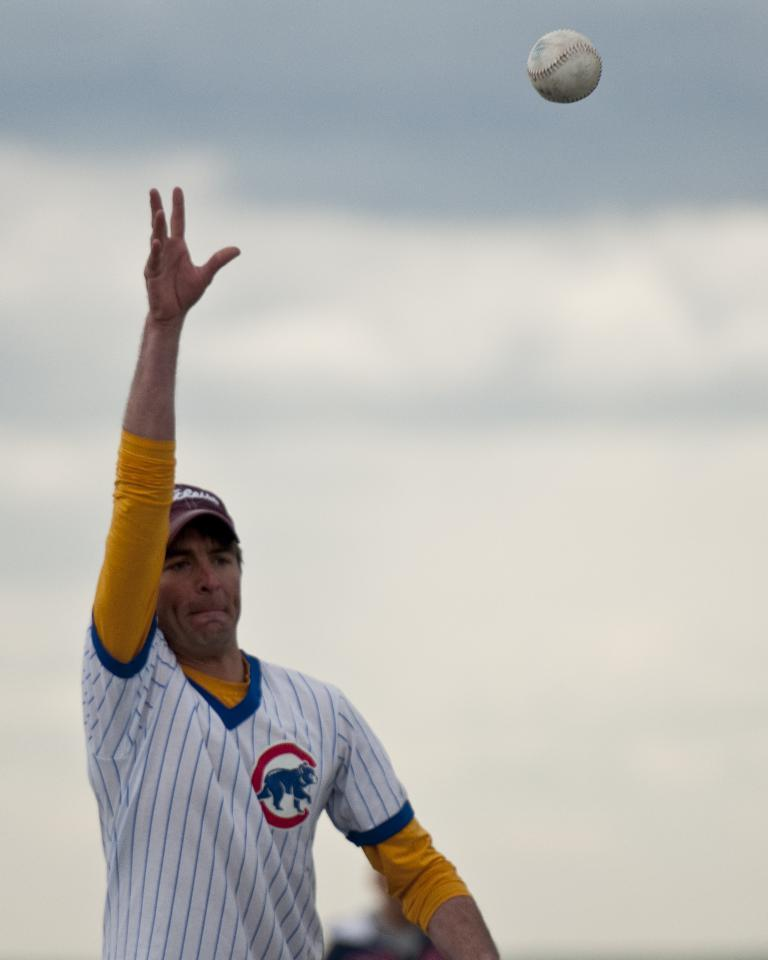Who is present in the image? There is a man in the image. What is happening with the ball in the image? The ball is in the air in the image. What can be seen in the background of the image? The sky is visible in the background of the image. Where is the harbor located in the image? There is no harbor present in the image. How many crows are visible in the image? There are no crows present in the image. 